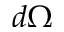Convert formula to latex. <formula><loc_0><loc_0><loc_500><loc_500>d \Omega</formula> 